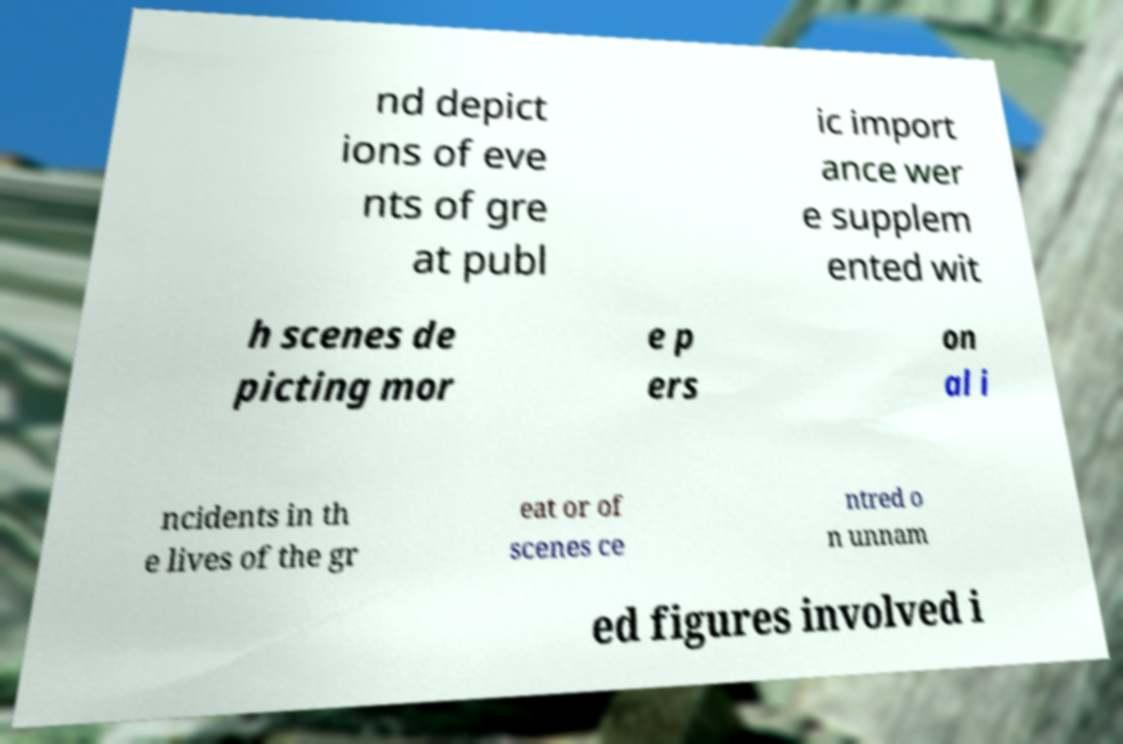I need the written content from this picture converted into text. Can you do that? nd depict ions of eve nts of gre at publ ic import ance wer e supplem ented wit h scenes de picting mor e p ers on al i ncidents in th e lives of the gr eat or of scenes ce ntred o n unnam ed figures involved i 